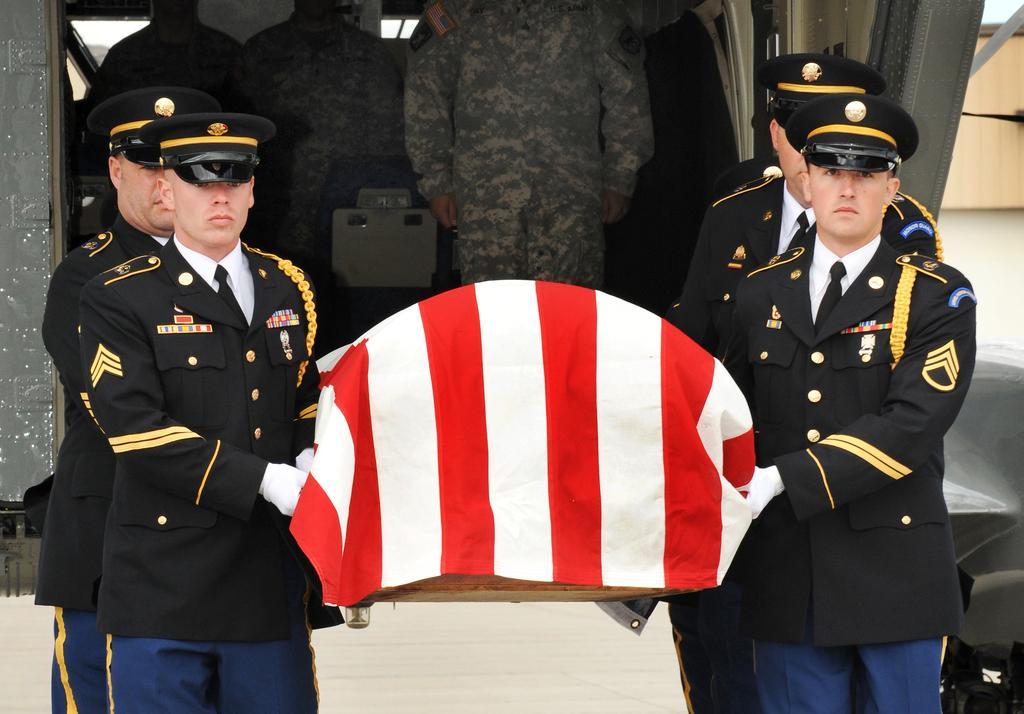Please provide a concise description of this image. In front of the image there are a few officers holding some object. Behind them there are a few people standing inside the vehicle. In the background of the image there is a wall. 